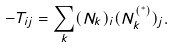Convert formula to latex. <formula><loc_0><loc_0><loc_500><loc_500>- T _ { i j } = \sum _ { k } ( N _ { k } ) _ { i } ( N _ { k } ^ { \left ( ^ { * } \right ) } ) _ { j } .</formula> 